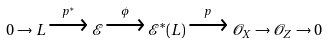<formula> <loc_0><loc_0><loc_500><loc_500>0 \to L \xrightarrow { p ^ { * } } \mathcal { E } \xrightarrow { \phi } \mathcal { E } ^ { * } ( L ) \xrightarrow { \, p \, } \mathcal { O } _ { X } \to \mathcal { O } _ { Z } \to 0</formula> 